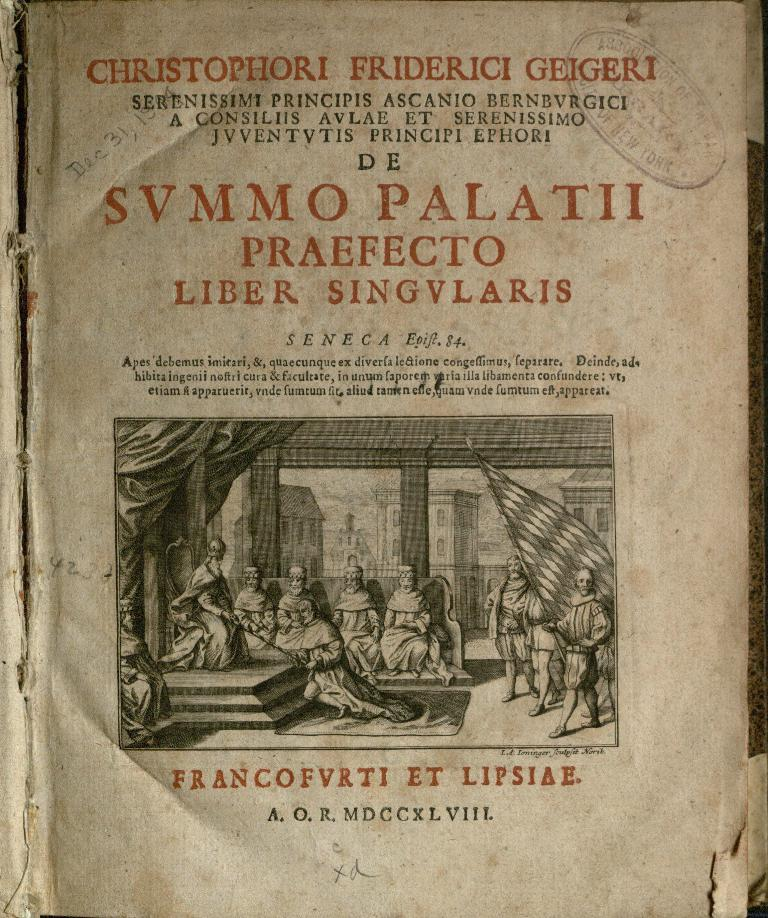Provide a one-sentence caption for the provided image. An ancient looking book with curled edges titled SVMMO PALATII. 